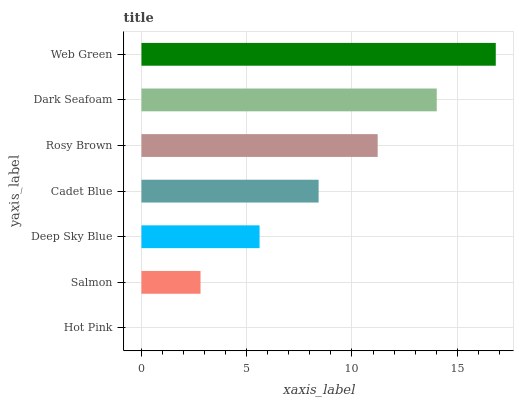Is Hot Pink the minimum?
Answer yes or no. Yes. Is Web Green the maximum?
Answer yes or no. Yes. Is Salmon the minimum?
Answer yes or no. No. Is Salmon the maximum?
Answer yes or no. No. Is Salmon greater than Hot Pink?
Answer yes or no. Yes. Is Hot Pink less than Salmon?
Answer yes or no. Yes. Is Hot Pink greater than Salmon?
Answer yes or no. No. Is Salmon less than Hot Pink?
Answer yes or no. No. Is Cadet Blue the high median?
Answer yes or no. Yes. Is Cadet Blue the low median?
Answer yes or no. Yes. Is Hot Pink the high median?
Answer yes or no. No. Is Hot Pink the low median?
Answer yes or no. No. 